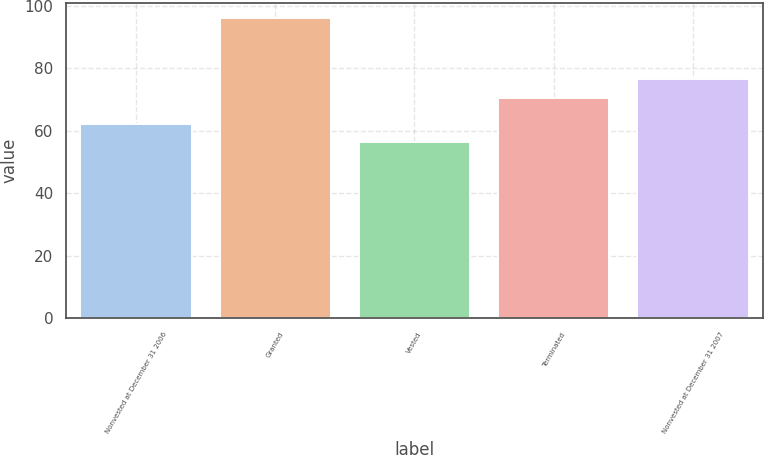Convert chart. <chart><loc_0><loc_0><loc_500><loc_500><bar_chart><fcel>Nonvested at December 31 2006<fcel>Granted<fcel>Vested<fcel>Terminated<fcel>Nonvested at December 31 2007<nl><fcel>62.27<fcel>96.13<fcel>56.25<fcel>70.33<fcel>76.6<nl></chart> 